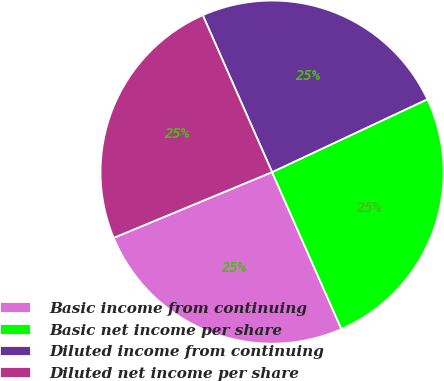Convert chart to OTSL. <chart><loc_0><loc_0><loc_500><loc_500><pie_chart><fcel>Basic income from continuing<fcel>Basic net income per share<fcel>Diluted income from continuing<fcel>Diluted net income per share<nl><fcel>25.36%<fcel>25.36%<fcel>24.64%<fcel>24.64%<nl></chart> 